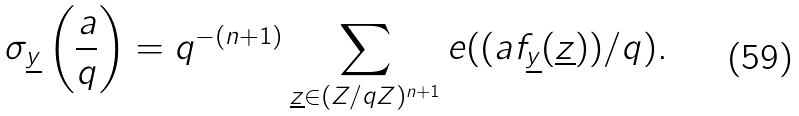Convert formula to latex. <formula><loc_0><loc_0><loc_500><loc_500>\sigma _ { \underline { y } } \left ( \frac { a } { q } \right ) = q ^ { - ( n + 1 ) } \sum _ { \underline { z } \in ( Z / q Z ) ^ { n + 1 } } e ( ( a f _ { \underline { y } } ( \underline { z } ) ) / q ) .</formula> 